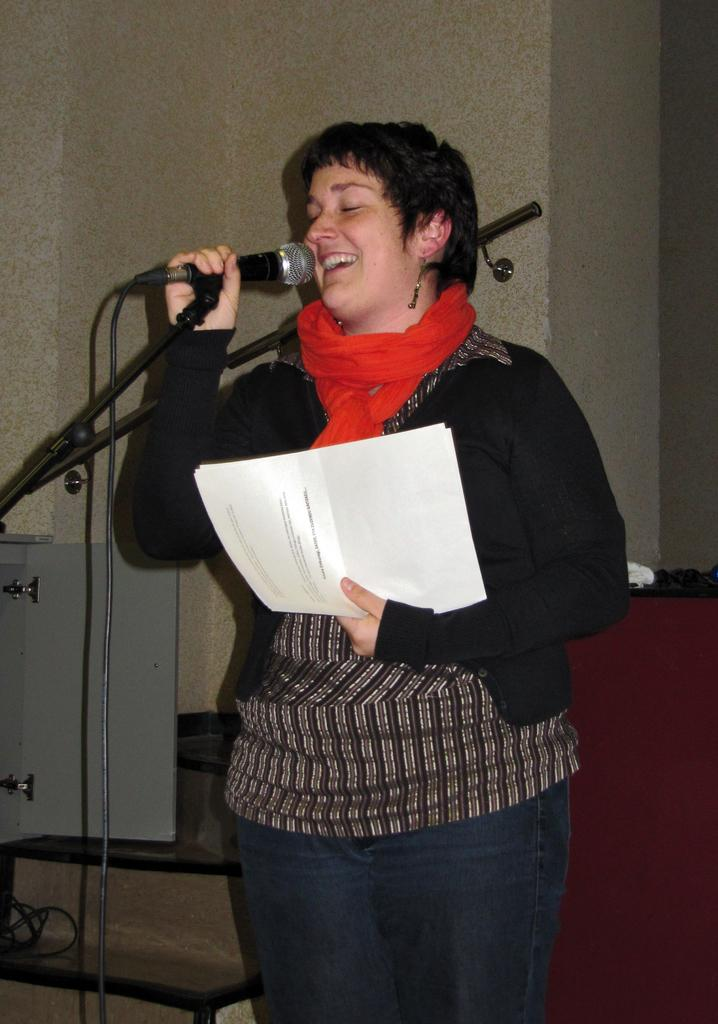Who is the main subject in the image? There is a lady in the image. What is the lady wearing? The lady is wearing a black jacket and a red scarf. What is the lady holding in her hand? The lady is holding papers in her hand. What is the lady doing in the image? The lady is singing through a mic. What can be seen in the background of the image? There are stairs in the background of the image. How many bananas are on the table next to the lady in the image? There are no bananas present in the image. Can you tell me how many friends are standing next to the lady in the image? There is no mention of friends in the image; it only features the lady. What type of babies are visible in the image? There are no babies present in the image. 